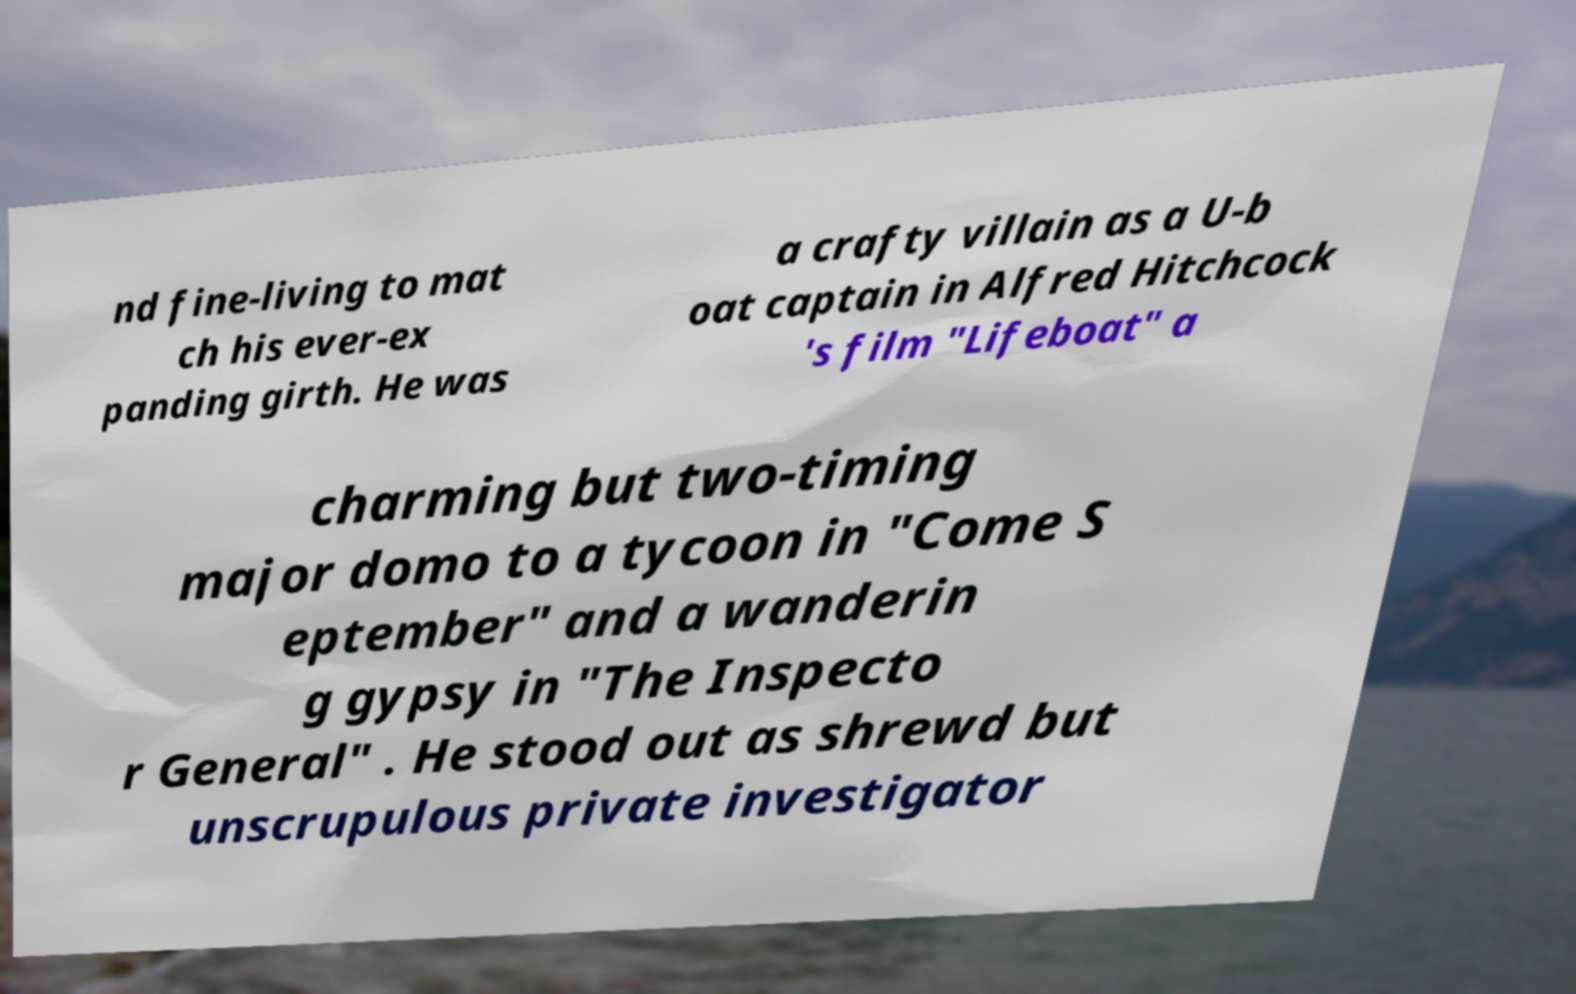Please read and relay the text visible in this image. What does it say? nd fine-living to mat ch his ever-ex panding girth. He was a crafty villain as a U-b oat captain in Alfred Hitchcock 's film "Lifeboat" a charming but two-timing major domo to a tycoon in "Come S eptember" and a wanderin g gypsy in "The Inspecto r General" . He stood out as shrewd but unscrupulous private investigator 